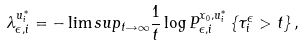<formula> <loc_0><loc_0><loc_500><loc_500>\lambda _ { \epsilon , i } ^ { u _ { i } ^ { \ast } } = - \lim s u p _ { t \rightarrow \infty } \frac { 1 } { t } \log P _ { \epsilon , i } ^ { x _ { 0 } , u _ { i } ^ { \ast } } \left \{ \tau _ { i } ^ { \epsilon } > t \right \} ,</formula> 